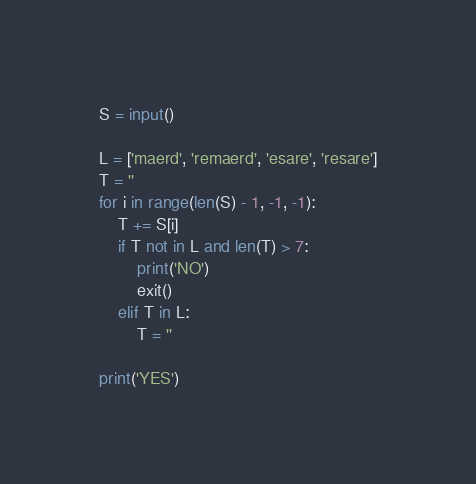<code> <loc_0><loc_0><loc_500><loc_500><_Python_>S = input()

L = ['maerd', 'remaerd', 'esare', 'resare']
T = ''
for i in range(len(S) - 1, -1, -1):
    T += S[i]
    if T not in L and len(T) > 7:
        print('NO')
        exit()
    elif T in L:
        T = ''

print('YES')
</code> 